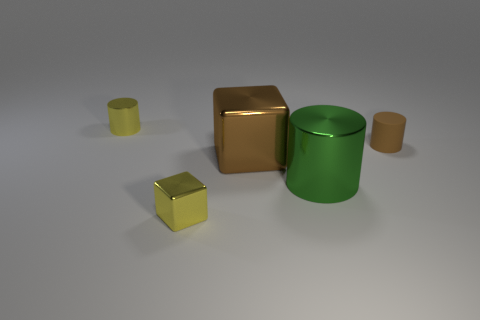Add 1 large purple spheres. How many objects exist? 6 Subtract all big green cylinders. How many cylinders are left? 2 Subtract all cylinders. How many objects are left? 2 Subtract all red cylinders. How many red cubes are left? 0 Subtract all yellow objects. Subtract all yellow metal cubes. How many objects are left? 2 Add 1 metal things. How many metal things are left? 5 Add 5 big cyan objects. How many big cyan objects exist? 5 Subtract all yellow cubes. How many cubes are left? 1 Subtract 0 brown balls. How many objects are left? 5 Subtract 2 blocks. How many blocks are left? 0 